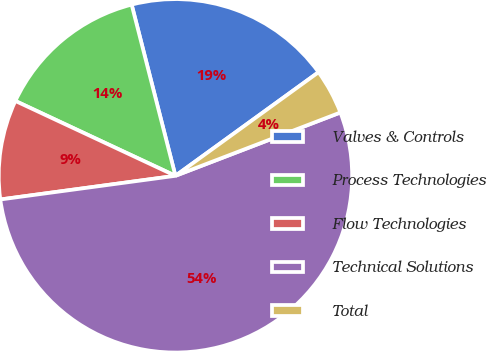<chart> <loc_0><loc_0><loc_500><loc_500><pie_chart><fcel>Valves & Controls<fcel>Process Technologies<fcel>Flow Technologies<fcel>Technical Solutions<fcel>Total<nl><fcel>19.01%<fcel>14.05%<fcel>9.1%<fcel>53.69%<fcel>4.14%<nl></chart> 